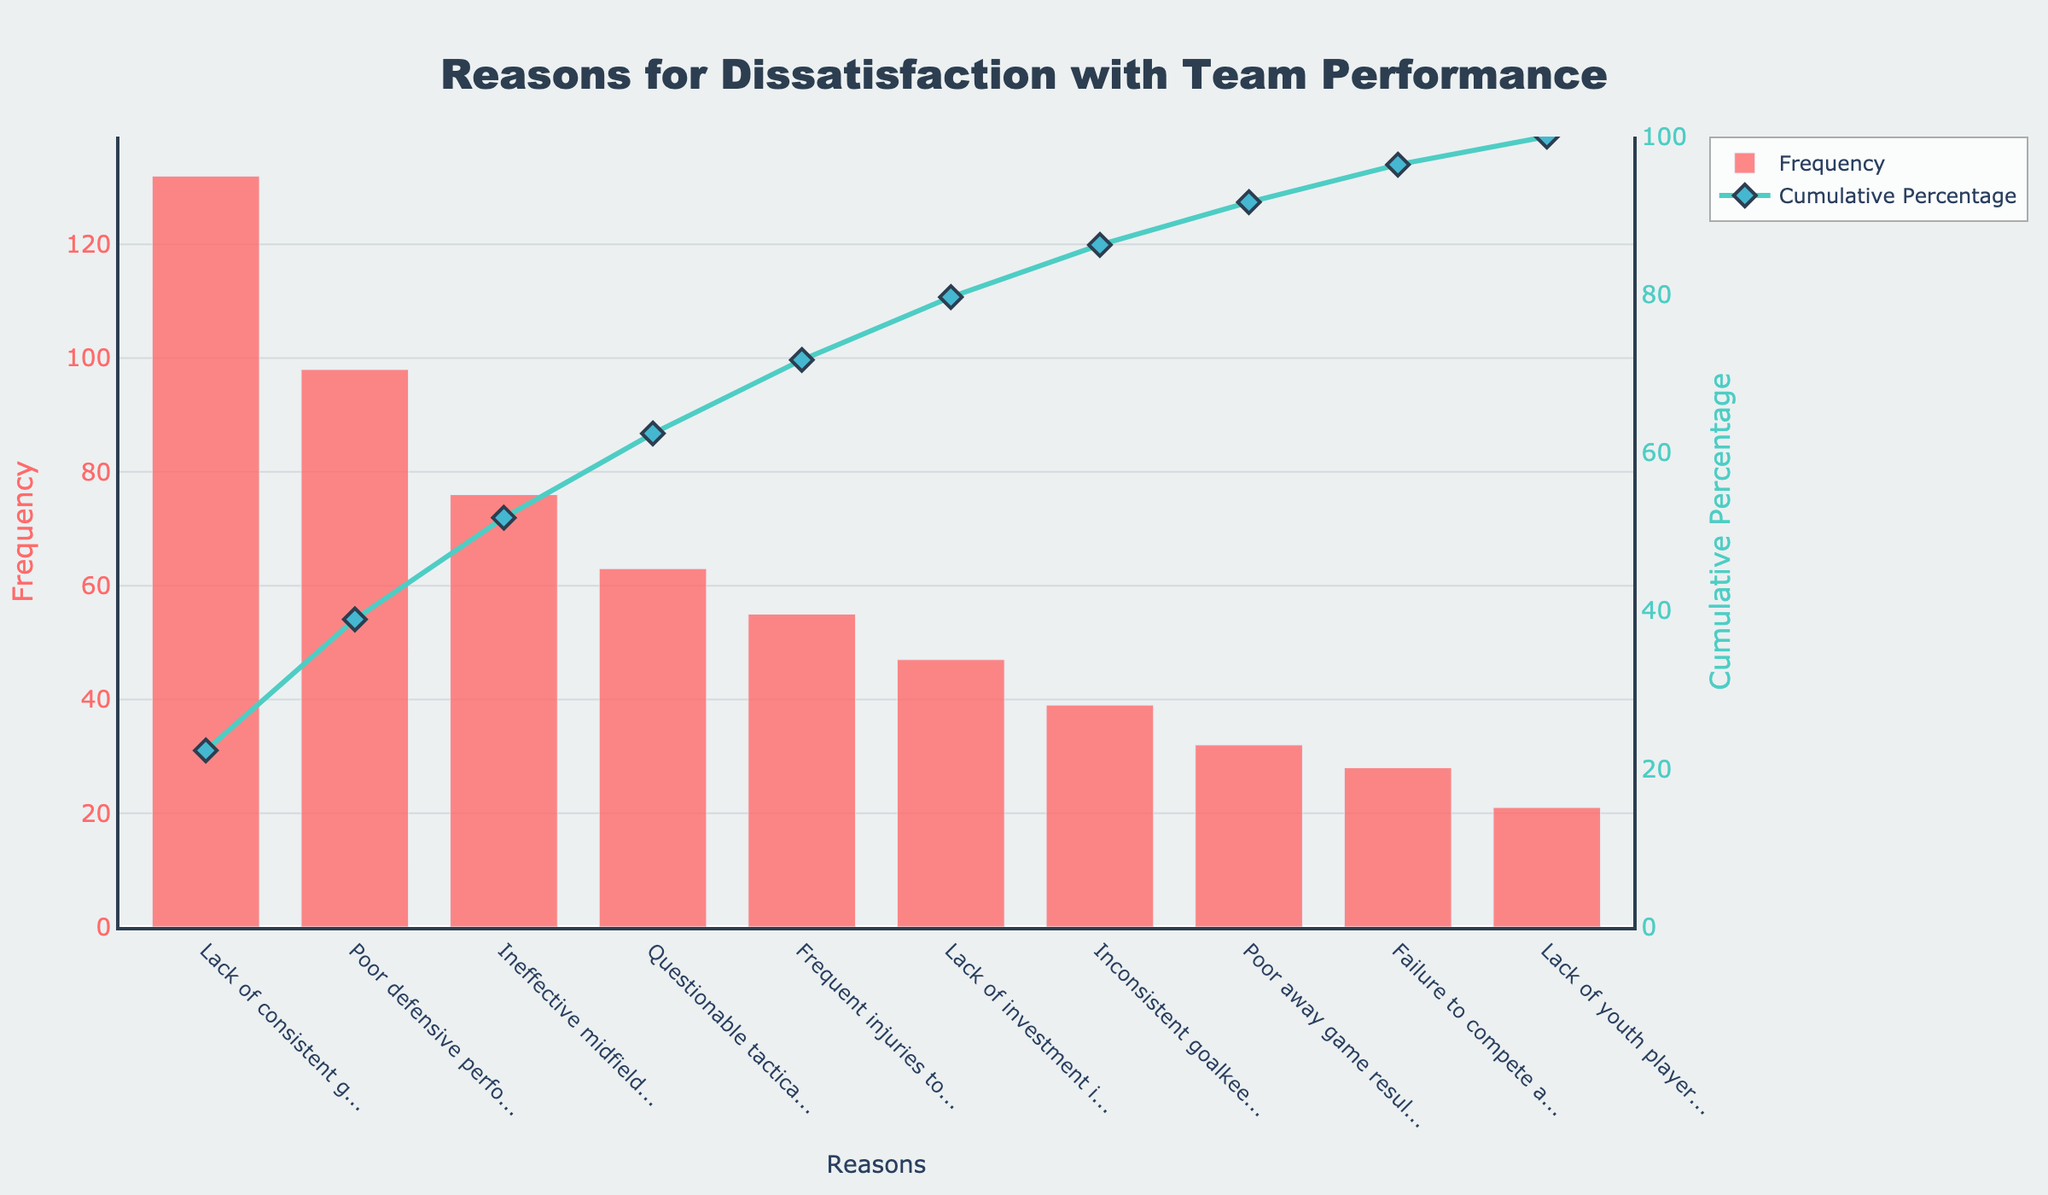What is the most frequent reason for dissatisfaction with team performance? The most frequent reason can be identified by looking at the highest bar in the figure. The tallest bar corresponds to "Lack of consistent goal-scoring."
Answer: Lack of consistent goal-scoring What percentage of complaints does "Poor defensive performance" contribute? Identify the bar labeled "Poor defensive performance" and check the corresponding cumulative percentage in the figure, which shows approximately 53%. Then calculate the percentage contribution of just this reason from the data: 98 out of the total number of complaints.
Answer: 24.4% What are the top three reasons for dissatisfaction, based on frequency? The top three reasons can be identified by looking at the first three highest bars. They correspond to "Lack of consistent goal-scoring," "Poor defensive performance," and "Ineffective midfield play."
Answer: Lack of consistent goal-scoring, Poor defensive performance, Ineffective midfield play How many complaints are there in total? The total number of complaints can be obtained by summing all the frequencies of the bars in the figure. Adding them up: 132+98+76+63+55+47+39+32+28+21.
Answer: 591 What is the cumulative percentage after including "Frequent injuries to key players"? The cumulative percentage for "Frequent injuries to key players" can be found by looking at the cumulative percentage line at that data point, which is around 70%.
Answer: 70% Which reason has the lowest frequency of complaints? The lowest frequency can be identified by finding the shortest bar in the figure. This corresponds to "Lack of youth player development."
Answer: Lack of youth player development How does the complaint "Questionable tactical decisions by manager" rank in frequency compared to "Frequent injuries to key players"? Compare the height of the bars for "Questionable tactical decisions by manager" and "Frequent injuries to key players". The former has more complaints than the latter.
Answer: Higher What is the cumulative percentage up to "Lack of investment in new signings"? The cumulative percentage can be found by looking at the line representing cumulative percentage right above "Lack of investment in new signings," which is approximately 80%.
Answer: 80% How many complaints are about "Lack of youth player development"? Identify the bar for "Lack of youth player development" and refer to its height which indicates 21 complaints.
Answer: 21 What is the second least frequent reason for dissatisfaction? Identify the second shortest bar in the figure which corresponds to "Failure to compete against top teams."
Answer: Failure to compete against top teams 